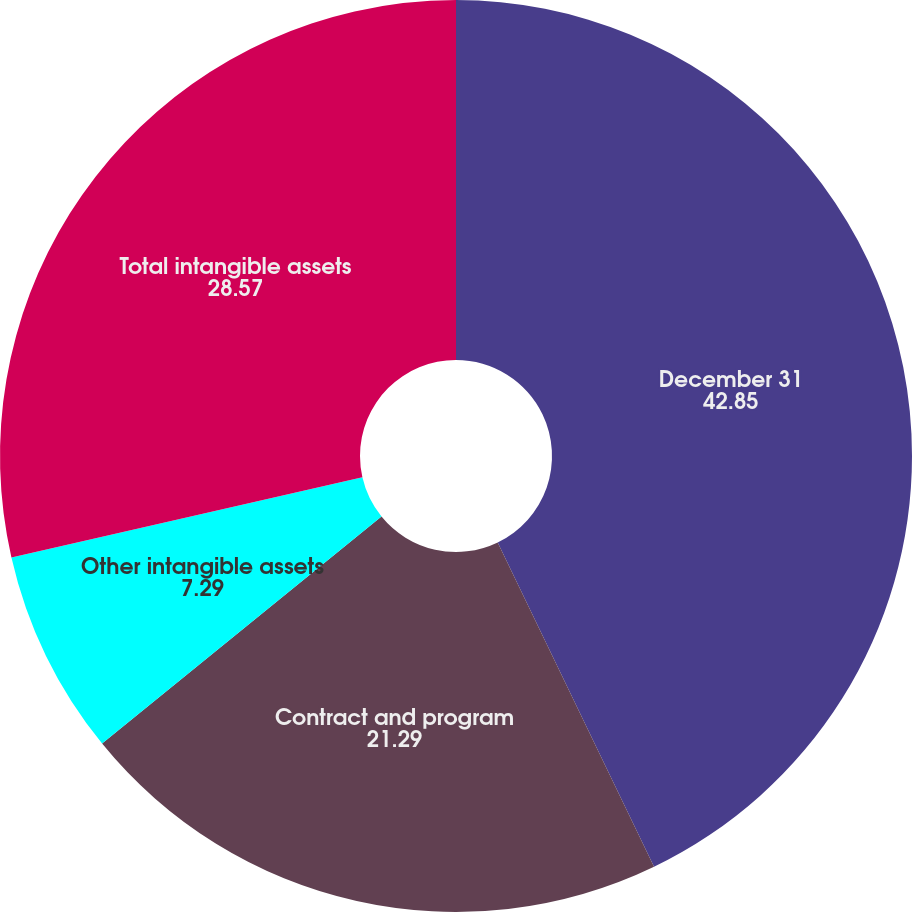Convert chart. <chart><loc_0><loc_0><loc_500><loc_500><pie_chart><fcel>December 31<fcel>Contract and program<fcel>Other intangible assets<fcel>Total intangible assets<nl><fcel>42.85%<fcel>21.29%<fcel>7.29%<fcel>28.57%<nl></chart> 